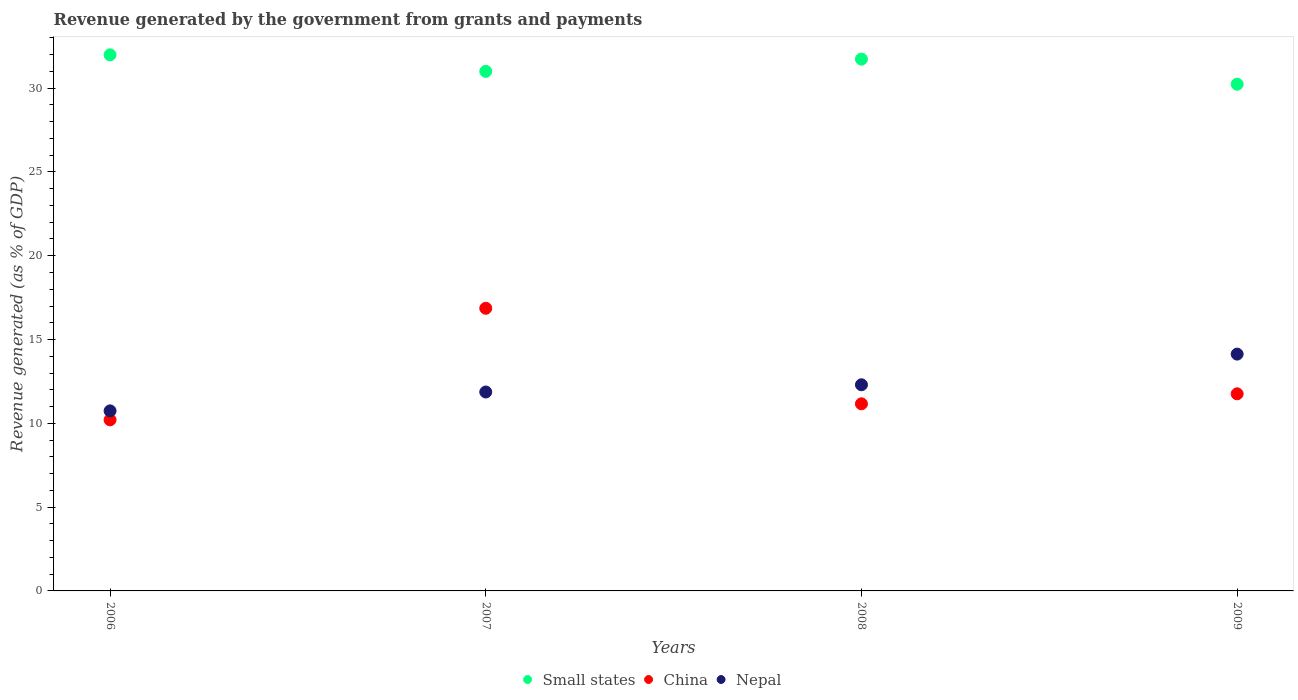Is the number of dotlines equal to the number of legend labels?
Your answer should be very brief. Yes. What is the revenue generated by the government in China in 2006?
Your answer should be compact. 10.21. Across all years, what is the maximum revenue generated by the government in Small states?
Your answer should be compact. 31.99. Across all years, what is the minimum revenue generated by the government in Small states?
Provide a succinct answer. 30.23. What is the total revenue generated by the government in Small states in the graph?
Keep it short and to the point. 124.95. What is the difference between the revenue generated by the government in China in 2007 and that in 2009?
Make the answer very short. 5.1. What is the difference between the revenue generated by the government in China in 2006 and the revenue generated by the government in Nepal in 2009?
Offer a terse response. -3.92. What is the average revenue generated by the government in China per year?
Provide a short and direct response. 12.5. In the year 2007, what is the difference between the revenue generated by the government in Nepal and revenue generated by the government in China?
Your answer should be very brief. -4.99. What is the ratio of the revenue generated by the government in Small states in 2006 to that in 2009?
Your answer should be very brief. 1.06. Is the revenue generated by the government in Small states in 2006 less than that in 2009?
Ensure brevity in your answer.  No. What is the difference between the highest and the second highest revenue generated by the government in Nepal?
Your response must be concise. 1.83. What is the difference between the highest and the lowest revenue generated by the government in China?
Keep it short and to the point. 6.66. Does the revenue generated by the government in Small states monotonically increase over the years?
Give a very brief answer. No. Is the revenue generated by the government in China strictly less than the revenue generated by the government in Small states over the years?
Your response must be concise. Yes. How many dotlines are there?
Ensure brevity in your answer.  3. What is the difference between two consecutive major ticks on the Y-axis?
Make the answer very short. 5. Does the graph contain any zero values?
Your answer should be very brief. No. Does the graph contain grids?
Provide a short and direct response. No. How many legend labels are there?
Offer a terse response. 3. How are the legend labels stacked?
Offer a terse response. Horizontal. What is the title of the graph?
Keep it short and to the point. Revenue generated by the government from grants and payments. What is the label or title of the X-axis?
Provide a short and direct response. Years. What is the label or title of the Y-axis?
Your answer should be very brief. Revenue generated (as % of GDP). What is the Revenue generated (as % of GDP) of Small states in 2006?
Offer a terse response. 31.99. What is the Revenue generated (as % of GDP) in China in 2006?
Keep it short and to the point. 10.21. What is the Revenue generated (as % of GDP) of Nepal in 2006?
Give a very brief answer. 10.74. What is the Revenue generated (as % of GDP) of Small states in 2007?
Ensure brevity in your answer.  31. What is the Revenue generated (as % of GDP) in China in 2007?
Provide a short and direct response. 16.86. What is the Revenue generated (as % of GDP) in Nepal in 2007?
Provide a short and direct response. 11.87. What is the Revenue generated (as % of GDP) of Small states in 2008?
Your response must be concise. 31.73. What is the Revenue generated (as % of GDP) in China in 2008?
Your answer should be compact. 11.16. What is the Revenue generated (as % of GDP) in Nepal in 2008?
Offer a very short reply. 12.3. What is the Revenue generated (as % of GDP) of Small states in 2009?
Your answer should be very brief. 30.23. What is the Revenue generated (as % of GDP) in China in 2009?
Provide a succinct answer. 11.76. What is the Revenue generated (as % of GDP) of Nepal in 2009?
Offer a very short reply. 14.13. Across all years, what is the maximum Revenue generated (as % of GDP) of Small states?
Offer a very short reply. 31.99. Across all years, what is the maximum Revenue generated (as % of GDP) in China?
Make the answer very short. 16.86. Across all years, what is the maximum Revenue generated (as % of GDP) in Nepal?
Your answer should be very brief. 14.13. Across all years, what is the minimum Revenue generated (as % of GDP) of Small states?
Your answer should be compact. 30.23. Across all years, what is the minimum Revenue generated (as % of GDP) in China?
Your response must be concise. 10.21. Across all years, what is the minimum Revenue generated (as % of GDP) in Nepal?
Give a very brief answer. 10.74. What is the total Revenue generated (as % of GDP) of Small states in the graph?
Your response must be concise. 124.95. What is the total Revenue generated (as % of GDP) of China in the graph?
Provide a short and direct response. 50. What is the total Revenue generated (as % of GDP) of Nepal in the graph?
Give a very brief answer. 49.04. What is the difference between the Revenue generated (as % of GDP) in Small states in 2006 and that in 2007?
Give a very brief answer. 0.99. What is the difference between the Revenue generated (as % of GDP) of China in 2006 and that in 2007?
Give a very brief answer. -6.66. What is the difference between the Revenue generated (as % of GDP) in Nepal in 2006 and that in 2007?
Your answer should be very brief. -1.13. What is the difference between the Revenue generated (as % of GDP) of Small states in 2006 and that in 2008?
Your response must be concise. 0.26. What is the difference between the Revenue generated (as % of GDP) of China in 2006 and that in 2008?
Provide a succinct answer. -0.96. What is the difference between the Revenue generated (as % of GDP) of Nepal in 2006 and that in 2008?
Give a very brief answer. -1.56. What is the difference between the Revenue generated (as % of GDP) in Small states in 2006 and that in 2009?
Keep it short and to the point. 1.75. What is the difference between the Revenue generated (as % of GDP) in China in 2006 and that in 2009?
Provide a succinct answer. -1.55. What is the difference between the Revenue generated (as % of GDP) in Nepal in 2006 and that in 2009?
Give a very brief answer. -3.39. What is the difference between the Revenue generated (as % of GDP) in Small states in 2007 and that in 2008?
Your response must be concise. -0.73. What is the difference between the Revenue generated (as % of GDP) in China in 2007 and that in 2008?
Offer a terse response. 5.7. What is the difference between the Revenue generated (as % of GDP) in Nepal in 2007 and that in 2008?
Your answer should be very brief. -0.43. What is the difference between the Revenue generated (as % of GDP) of Small states in 2007 and that in 2009?
Provide a succinct answer. 0.77. What is the difference between the Revenue generated (as % of GDP) in China in 2007 and that in 2009?
Make the answer very short. 5.1. What is the difference between the Revenue generated (as % of GDP) in Nepal in 2007 and that in 2009?
Offer a terse response. -2.26. What is the difference between the Revenue generated (as % of GDP) in Small states in 2008 and that in 2009?
Your response must be concise. 1.5. What is the difference between the Revenue generated (as % of GDP) in China in 2008 and that in 2009?
Provide a succinct answer. -0.6. What is the difference between the Revenue generated (as % of GDP) of Nepal in 2008 and that in 2009?
Keep it short and to the point. -1.83. What is the difference between the Revenue generated (as % of GDP) of Small states in 2006 and the Revenue generated (as % of GDP) of China in 2007?
Offer a terse response. 15.12. What is the difference between the Revenue generated (as % of GDP) of Small states in 2006 and the Revenue generated (as % of GDP) of Nepal in 2007?
Ensure brevity in your answer.  20.12. What is the difference between the Revenue generated (as % of GDP) of China in 2006 and the Revenue generated (as % of GDP) of Nepal in 2007?
Keep it short and to the point. -1.66. What is the difference between the Revenue generated (as % of GDP) in Small states in 2006 and the Revenue generated (as % of GDP) in China in 2008?
Offer a terse response. 20.82. What is the difference between the Revenue generated (as % of GDP) of Small states in 2006 and the Revenue generated (as % of GDP) of Nepal in 2008?
Ensure brevity in your answer.  19.69. What is the difference between the Revenue generated (as % of GDP) of China in 2006 and the Revenue generated (as % of GDP) of Nepal in 2008?
Ensure brevity in your answer.  -2.09. What is the difference between the Revenue generated (as % of GDP) in Small states in 2006 and the Revenue generated (as % of GDP) in China in 2009?
Provide a short and direct response. 20.23. What is the difference between the Revenue generated (as % of GDP) of Small states in 2006 and the Revenue generated (as % of GDP) of Nepal in 2009?
Make the answer very short. 17.86. What is the difference between the Revenue generated (as % of GDP) in China in 2006 and the Revenue generated (as % of GDP) in Nepal in 2009?
Give a very brief answer. -3.92. What is the difference between the Revenue generated (as % of GDP) in Small states in 2007 and the Revenue generated (as % of GDP) in China in 2008?
Give a very brief answer. 19.84. What is the difference between the Revenue generated (as % of GDP) in Small states in 2007 and the Revenue generated (as % of GDP) in Nepal in 2008?
Keep it short and to the point. 18.7. What is the difference between the Revenue generated (as % of GDP) in China in 2007 and the Revenue generated (as % of GDP) in Nepal in 2008?
Provide a succinct answer. 4.56. What is the difference between the Revenue generated (as % of GDP) in Small states in 2007 and the Revenue generated (as % of GDP) in China in 2009?
Give a very brief answer. 19.24. What is the difference between the Revenue generated (as % of GDP) of Small states in 2007 and the Revenue generated (as % of GDP) of Nepal in 2009?
Your answer should be compact. 16.87. What is the difference between the Revenue generated (as % of GDP) of China in 2007 and the Revenue generated (as % of GDP) of Nepal in 2009?
Your answer should be compact. 2.73. What is the difference between the Revenue generated (as % of GDP) in Small states in 2008 and the Revenue generated (as % of GDP) in China in 2009?
Offer a terse response. 19.97. What is the difference between the Revenue generated (as % of GDP) of Small states in 2008 and the Revenue generated (as % of GDP) of Nepal in 2009?
Offer a very short reply. 17.6. What is the difference between the Revenue generated (as % of GDP) of China in 2008 and the Revenue generated (as % of GDP) of Nepal in 2009?
Your answer should be very brief. -2.97. What is the average Revenue generated (as % of GDP) in Small states per year?
Your answer should be compact. 31.24. What is the average Revenue generated (as % of GDP) of China per year?
Offer a very short reply. 12.5. What is the average Revenue generated (as % of GDP) of Nepal per year?
Ensure brevity in your answer.  12.26. In the year 2006, what is the difference between the Revenue generated (as % of GDP) in Small states and Revenue generated (as % of GDP) in China?
Give a very brief answer. 21.78. In the year 2006, what is the difference between the Revenue generated (as % of GDP) in Small states and Revenue generated (as % of GDP) in Nepal?
Provide a succinct answer. 21.24. In the year 2006, what is the difference between the Revenue generated (as % of GDP) in China and Revenue generated (as % of GDP) in Nepal?
Give a very brief answer. -0.54. In the year 2007, what is the difference between the Revenue generated (as % of GDP) of Small states and Revenue generated (as % of GDP) of China?
Your answer should be very brief. 14.14. In the year 2007, what is the difference between the Revenue generated (as % of GDP) of Small states and Revenue generated (as % of GDP) of Nepal?
Your response must be concise. 19.13. In the year 2007, what is the difference between the Revenue generated (as % of GDP) of China and Revenue generated (as % of GDP) of Nepal?
Your answer should be very brief. 4.99. In the year 2008, what is the difference between the Revenue generated (as % of GDP) in Small states and Revenue generated (as % of GDP) in China?
Provide a short and direct response. 20.57. In the year 2008, what is the difference between the Revenue generated (as % of GDP) of Small states and Revenue generated (as % of GDP) of Nepal?
Your response must be concise. 19.43. In the year 2008, what is the difference between the Revenue generated (as % of GDP) of China and Revenue generated (as % of GDP) of Nepal?
Offer a terse response. -1.14. In the year 2009, what is the difference between the Revenue generated (as % of GDP) of Small states and Revenue generated (as % of GDP) of China?
Your answer should be compact. 18.47. In the year 2009, what is the difference between the Revenue generated (as % of GDP) in Small states and Revenue generated (as % of GDP) in Nepal?
Your answer should be compact. 16.1. In the year 2009, what is the difference between the Revenue generated (as % of GDP) of China and Revenue generated (as % of GDP) of Nepal?
Offer a very short reply. -2.37. What is the ratio of the Revenue generated (as % of GDP) of Small states in 2006 to that in 2007?
Offer a terse response. 1.03. What is the ratio of the Revenue generated (as % of GDP) in China in 2006 to that in 2007?
Your answer should be compact. 0.61. What is the ratio of the Revenue generated (as % of GDP) in Nepal in 2006 to that in 2007?
Provide a succinct answer. 0.91. What is the ratio of the Revenue generated (as % of GDP) of Small states in 2006 to that in 2008?
Make the answer very short. 1.01. What is the ratio of the Revenue generated (as % of GDP) of China in 2006 to that in 2008?
Your response must be concise. 0.91. What is the ratio of the Revenue generated (as % of GDP) in Nepal in 2006 to that in 2008?
Make the answer very short. 0.87. What is the ratio of the Revenue generated (as % of GDP) of Small states in 2006 to that in 2009?
Give a very brief answer. 1.06. What is the ratio of the Revenue generated (as % of GDP) in China in 2006 to that in 2009?
Your answer should be very brief. 0.87. What is the ratio of the Revenue generated (as % of GDP) in Nepal in 2006 to that in 2009?
Give a very brief answer. 0.76. What is the ratio of the Revenue generated (as % of GDP) of Small states in 2007 to that in 2008?
Offer a terse response. 0.98. What is the ratio of the Revenue generated (as % of GDP) of China in 2007 to that in 2008?
Ensure brevity in your answer.  1.51. What is the ratio of the Revenue generated (as % of GDP) of Nepal in 2007 to that in 2008?
Give a very brief answer. 0.96. What is the ratio of the Revenue generated (as % of GDP) of Small states in 2007 to that in 2009?
Your response must be concise. 1.03. What is the ratio of the Revenue generated (as % of GDP) of China in 2007 to that in 2009?
Your answer should be very brief. 1.43. What is the ratio of the Revenue generated (as % of GDP) in Nepal in 2007 to that in 2009?
Offer a very short reply. 0.84. What is the ratio of the Revenue generated (as % of GDP) of Small states in 2008 to that in 2009?
Give a very brief answer. 1.05. What is the ratio of the Revenue generated (as % of GDP) in China in 2008 to that in 2009?
Give a very brief answer. 0.95. What is the ratio of the Revenue generated (as % of GDP) of Nepal in 2008 to that in 2009?
Keep it short and to the point. 0.87. What is the difference between the highest and the second highest Revenue generated (as % of GDP) in Small states?
Your answer should be compact. 0.26. What is the difference between the highest and the second highest Revenue generated (as % of GDP) of China?
Your answer should be very brief. 5.1. What is the difference between the highest and the second highest Revenue generated (as % of GDP) of Nepal?
Give a very brief answer. 1.83. What is the difference between the highest and the lowest Revenue generated (as % of GDP) of Small states?
Offer a very short reply. 1.75. What is the difference between the highest and the lowest Revenue generated (as % of GDP) in China?
Your response must be concise. 6.66. What is the difference between the highest and the lowest Revenue generated (as % of GDP) in Nepal?
Provide a short and direct response. 3.39. 